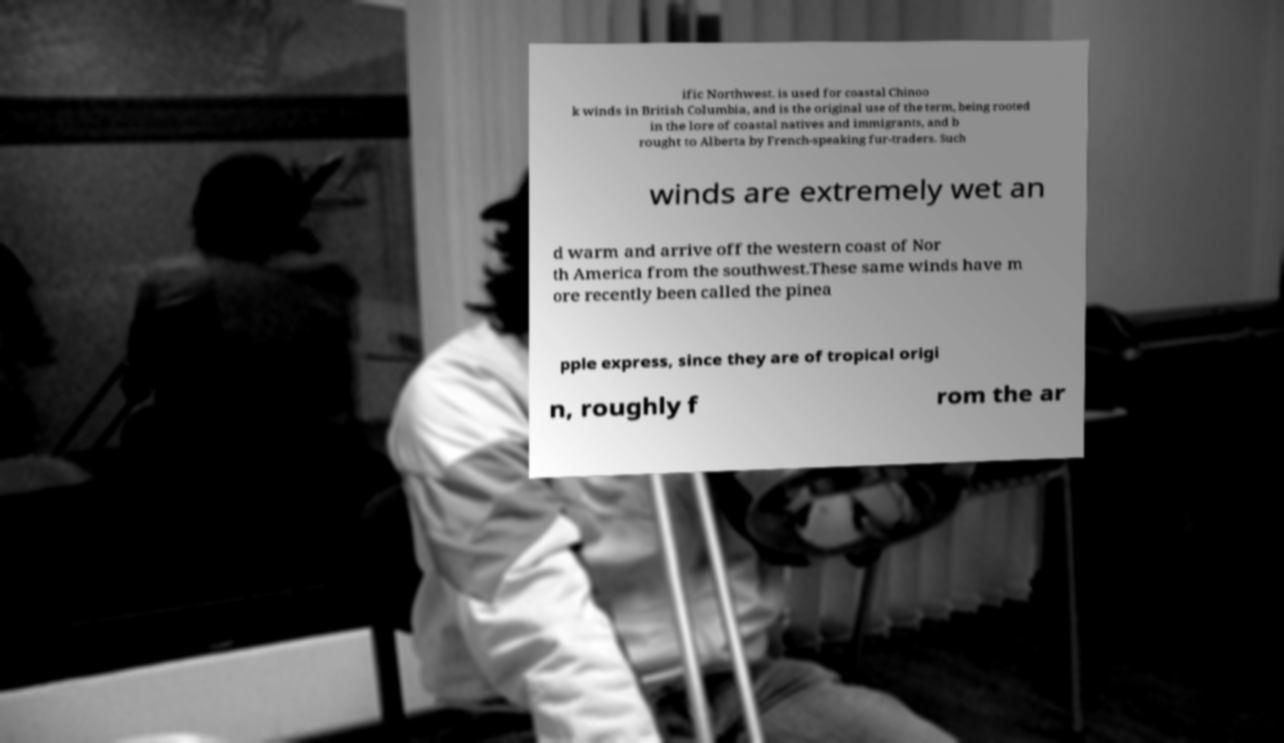What messages or text are displayed in this image? I need them in a readable, typed format. ific Northwest. is used for coastal Chinoo k winds in British Columbia, and is the original use of the term, being rooted in the lore of coastal natives and immigrants, and b rought to Alberta by French-speaking fur-traders. Such winds are extremely wet an d warm and arrive off the western coast of Nor th America from the southwest.These same winds have m ore recently been called the pinea pple express, since they are of tropical origi n, roughly f rom the ar 